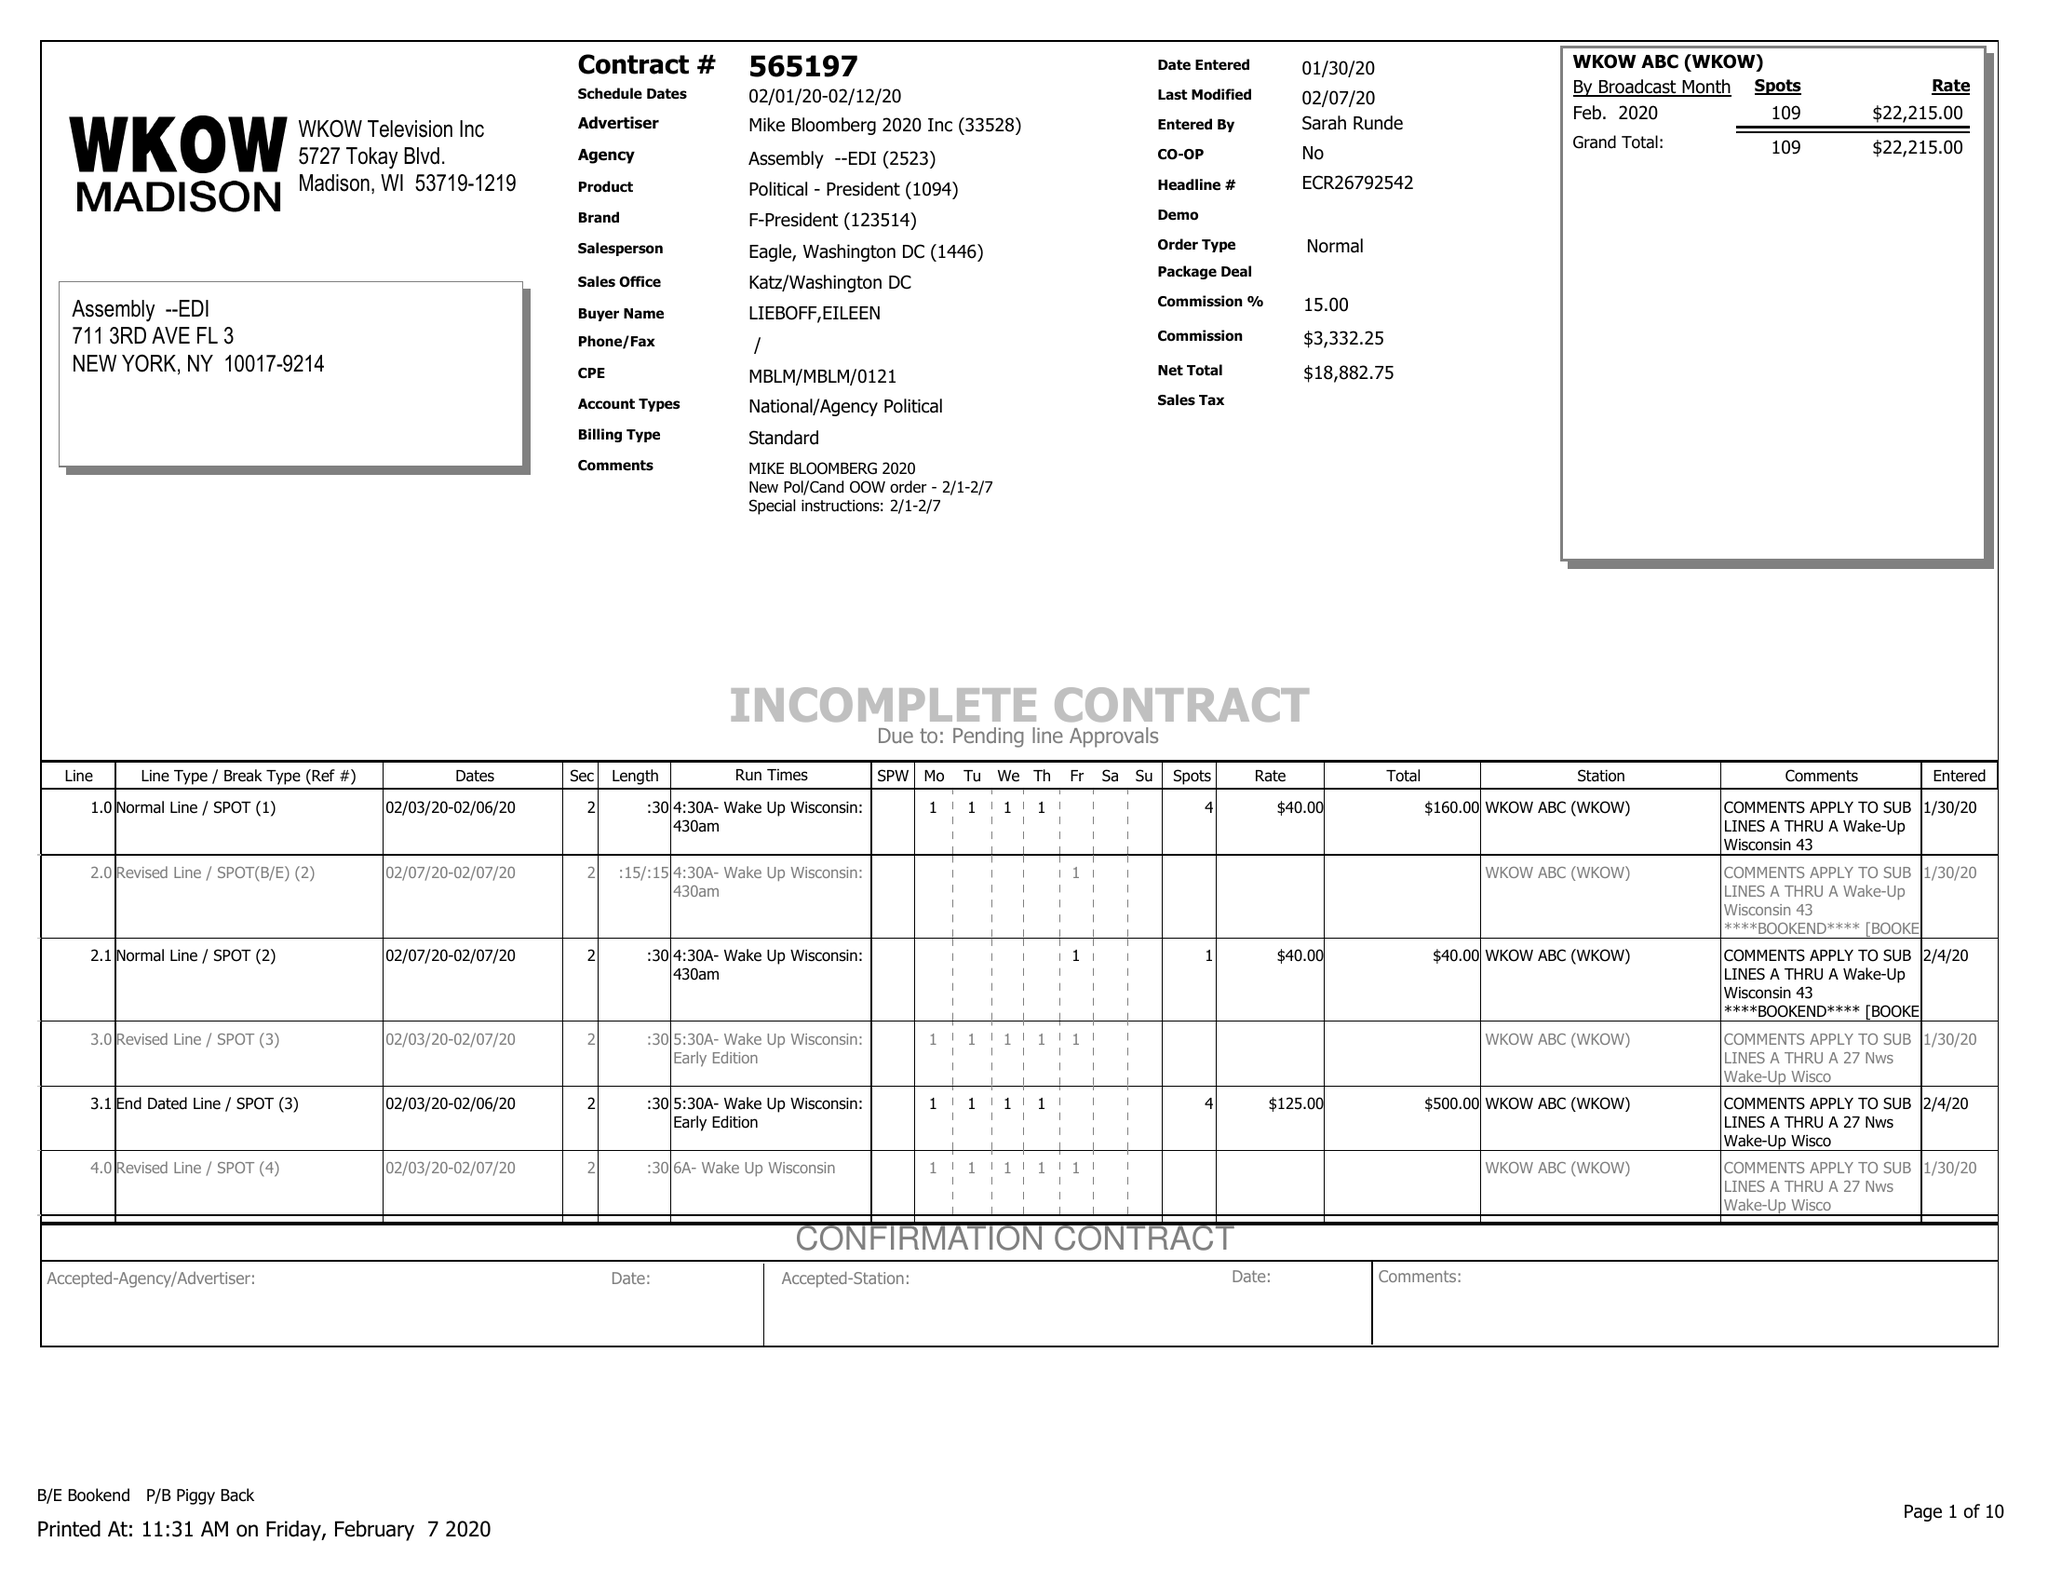What is the value for the advertiser?
Answer the question using a single word or phrase. MIKE BLOOMBERG 2020 INC 